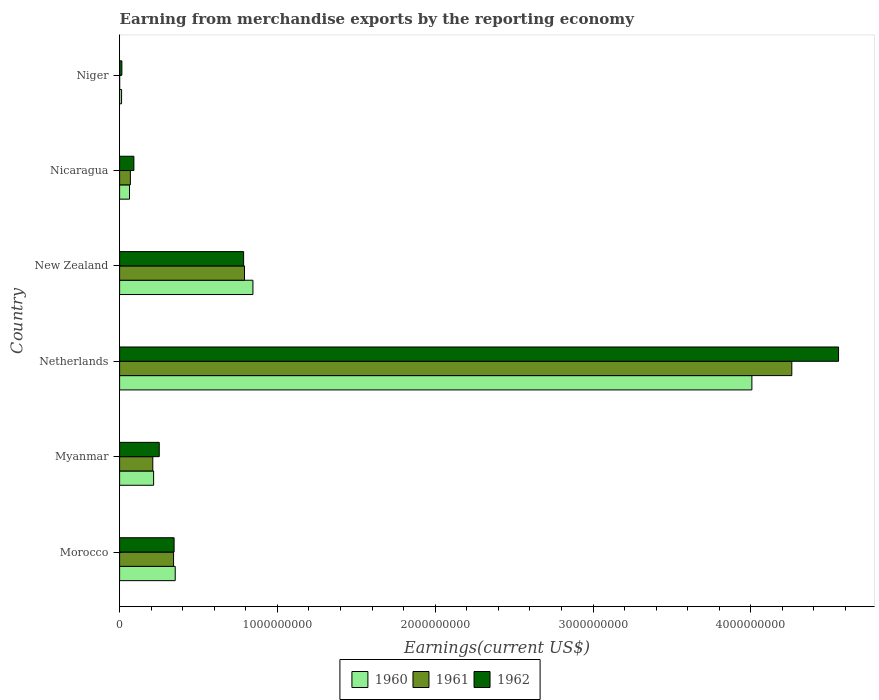How many different coloured bars are there?
Provide a succinct answer. 3. How many groups of bars are there?
Make the answer very short. 6. Are the number of bars per tick equal to the number of legend labels?
Keep it short and to the point. Yes. In how many cases, is the number of bars for a given country not equal to the number of legend labels?
Provide a succinct answer. 0. What is the amount earned from merchandise exports in 1962 in Myanmar?
Your response must be concise. 2.51e+08. Across all countries, what is the maximum amount earned from merchandise exports in 1960?
Offer a very short reply. 4.01e+09. Across all countries, what is the minimum amount earned from merchandise exports in 1960?
Provide a succinct answer. 1.25e+07. In which country was the amount earned from merchandise exports in 1962 maximum?
Offer a very short reply. Netherlands. In which country was the amount earned from merchandise exports in 1962 minimum?
Your answer should be very brief. Niger. What is the total amount earned from merchandise exports in 1960 in the graph?
Your answer should be compact. 5.49e+09. What is the difference between the amount earned from merchandise exports in 1961 in Nicaragua and that in Niger?
Offer a very short reply. 6.81e+07. What is the difference between the amount earned from merchandise exports in 1960 in Myanmar and the amount earned from merchandise exports in 1961 in Niger?
Keep it short and to the point. 2.15e+08. What is the average amount earned from merchandise exports in 1960 per country?
Your answer should be very brief. 9.16e+08. What is the difference between the amount earned from merchandise exports in 1962 and amount earned from merchandise exports in 1960 in Niger?
Your answer should be compact. 1.90e+06. In how many countries, is the amount earned from merchandise exports in 1960 greater than 800000000 US$?
Keep it short and to the point. 2. What is the ratio of the amount earned from merchandise exports in 1960 in New Zealand to that in Niger?
Keep it short and to the point. 67.59. Is the amount earned from merchandise exports in 1961 in New Zealand less than that in Nicaragua?
Offer a very short reply. No. What is the difference between the highest and the second highest amount earned from merchandise exports in 1960?
Keep it short and to the point. 3.16e+09. What is the difference between the highest and the lowest amount earned from merchandise exports in 1961?
Offer a very short reply. 4.26e+09. What does the 1st bar from the top in Netherlands represents?
Offer a very short reply. 1962. Is it the case that in every country, the sum of the amount earned from merchandise exports in 1962 and amount earned from merchandise exports in 1960 is greater than the amount earned from merchandise exports in 1961?
Keep it short and to the point. Yes. How many bars are there?
Provide a short and direct response. 18. How many countries are there in the graph?
Make the answer very short. 6. Are the values on the major ticks of X-axis written in scientific E-notation?
Give a very brief answer. No. Does the graph contain grids?
Your answer should be compact. No. Where does the legend appear in the graph?
Ensure brevity in your answer.  Bottom center. What is the title of the graph?
Your response must be concise. Earning from merchandise exports by the reporting economy. Does "2006" appear as one of the legend labels in the graph?
Offer a terse response. No. What is the label or title of the X-axis?
Your response must be concise. Earnings(current US$). What is the label or title of the Y-axis?
Make the answer very short. Country. What is the Earnings(current US$) in 1960 in Morocco?
Make the answer very short. 3.52e+08. What is the Earnings(current US$) of 1961 in Morocco?
Make the answer very short. 3.42e+08. What is the Earnings(current US$) in 1962 in Morocco?
Make the answer very short. 3.45e+08. What is the Earnings(current US$) in 1960 in Myanmar?
Offer a very short reply. 2.16e+08. What is the Earnings(current US$) of 1961 in Myanmar?
Provide a short and direct response. 2.10e+08. What is the Earnings(current US$) of 1962 in Myanmar?
Offer a terse response. 2.51e+08. What is the Earnings(current US$) of 1960 in Netherlands?
Your answer should be compact. 4.01e+09. What is the Earnings(current US$) in 1961 in Netherlands?
Your answer should be very brief. 4.26e+09. What is the Earnings(current US$) of 1962 in Netherlands?
Your response must be concise. 4.56e+09. What is the Earnings(current US$) in 1960 in New Zealand?
Offer a very short reply. 8.45e+08. What is the Earnings(current US$) in 1961 in New Zealand?
Your response must be concise. 7.92e+08. What is the Earnings(current US$) in 1962 in New Zealand?
Provide a short and direct response. 7.86e+08. What is the Earnings(current US$) in 1960 in Nicaragua?
Keep it short and to the point. 6.27e+07. What is the Earnings(current US$) in 1961 in Nicaragua?
Provide a short and direct response. 6.83e+07. What is the Earnings(current US$) in 1962 in Nicaragua?
Your answer should be very brief. 9.04e+07. What is the Earnings(current US$) of 1960 in Niger?
Ensure brevity in your answer.  1.25e+07. What is the Earnings(current US$) in 1962 in Niger?
Ensure brevity in your answer.  1.44e+07. Across all countries, what is the maximum Earnings(current US$) of 1960?
Provide a succinct answer. 4.01e+09. Across all countries, what is the maximum Earnings(current US$) in 1961?
Provide a short and direct response. 4.26e+09. Across all countries, what is the maximum Earnings(current US$) in 1962?
Give a very brief answer. 4.56e+09. Across all countries, what is the minimum Earnings(current US$) of 1960?
Provide a short and direct response. 1.25e+07. Across all countries, what is the minimum Earnings(current US$) of 1961?
Provide a short and direct response. 2.00e+05. Across all countries, what is the minimum Earnings(current US$) in 1962?
Keep it short and to the point. 1.44e+07. What is the total Earnings(current US$) of 1960 in the graph?
Provide a short and direct response. 5.49e+09. What is the total Earnings(current US$) of 1961 in the graph?
Provide a succinct answer. 5.67e+09. What is the total Earnings(current US$) in 1962 in the graph?
Keep it short and to the point. 6.04e+09. What is the difference between the Earnings(current US$) in 1960 in Morocco and that in Myanmar?
Provide a succinct answer. 1.37e+08. What is the difference between the Earnings(current US$) of 1961 in Morocco and that in Myanmar?
Your answer should be compact. 1.32e+08. What is the difference between the Earnings(current US$) in 1962 in Morocco and that in Myanmar?
Keep it short and to the point. 9.41e+07. What is the difference between the Earnings(current US$) in 1960 in Morocco and that in Netherlands?
Offer a very short reply. -3.65e+09. What is the difference between the Earnings(current US$) of 1961 in Morocco and that in Netherlands?
Keep it short and to the point. -3.92e+09. What is the difference between the Earnings(current US$) of 1962 in Morocco and that in Netherlands?
Your response must be concise. -4.21e+09. What is the difference between the Earnings(current US$) in 1960 in Morocco and that in New Zealand?
Provide a succinct answer. -4.92e+08. What is the difference between the Earnings(current US$) in 1961 in Morocco and that in New Zealand?
Offer a terse response. -4.50e+08. What is the difference between the Earnings(current US$) of 1962 in Morocco and that in New Zealand?
Your answer should be compact. -4.41e+08. What is the difference between the Earnings(current US$) in 1960 in Morocco and that in Nicaragua?
Make the answer very short. 2.90e+08. What is the difference between the Earnings(current US$) in 1961 in Morocco and that in Nicaragua?
Provide a short and direct response. 2.74e+08. What is the difference between the Earnings(current US$) in 1962 in Morocco and that in Nicaragua?
Your answer should be very brief. 2.55e+08. What is the difference between the Earnings(current US$) of 1960 in Morocco and that in Niger?
Give a very brief answer. 3.40e+08. What is the difference between the Earnings(current US$) of 1961 in Morocco and that in Niger?
Offer a terse response. 3.42e+08. What is the difference between the Earnings(current US$) of 1962 in Morocco and that in Niger?
Ensure brevity in your answer.  3.31e+08. What is the difference between the Earnings(current US$) in 1960 in Myanmar and that in Netherlands?
Keep it short and to the point. -3.79e+09. What is the difference between the Earnings(current US$) of 1961 in Myanmar and that in Netherlands?
Provide a succinct answer. -4.05e+09. What is the difference between the Earnings(current US$) of 1962 in Myanmar and that in Netherlands?
Provide a succinct answer. -4.30e+09. What is the difference between the Earnings(current US$) in 1960 in Myanmar and that in New Zealand?
Your response must be concise. -6.29e+08. What is the difference between the Earnings(current US$) of 1961 in Myanmar and that in New Zealand?
Your answer should be very brief. -5.81e+08. What is the difference between the Earnings(current US$) in 1962 in Myanmar and that in New Zealand?
Your answer should be compact. -5.35e+08. What is the difference between the Earnings(current US$) of 1960 in Myanmar and that in Nicaragua?
Provide a short and direct response. 1.53e+08. What is the difference between the Earnings(current US$) of 1961 in Myanmar and that in Nicaragua?
Keep it short and to the point. 1.42e+08. What is the difference between the Earnings(current US$) in 1962 in Myanmar and that in Nicaragua?
Ensure brevity in your answer.  1.61e+08. What is the difference between the Earnings(current US$) of 1960 in Myanmar and that in Niger?
Your response must be concise. 2.03e+08. What is the difference between the Earnings(current US$) in 1961 in Myanmar and that in Niger?
Offer a very short reply. 2.10e+08. What is the difference between the Earnings(current US$) in 1962 in Myanmar and that in Niger?
Offer a terse response. 2.37e+08. What is the difference between the Earnings(current US$) in 1960 in Netherlands and that in New Zealand?
Keep it short and to the point. 3.16e+09. What is the difference between the Earnings(current US$) in 1961 in Netherlands and that in New Zealand?
Offer a very short reply. 3.47e+09. What is the difference between the Earnings(current US$) in 1962 in Netherlands and that in New Zealand?
Provide a short and direct response. 3.77e+09. What is the difference between the Earnings(current US$) in 1960 in Netherlands and that in Nicaragua?
Your answer should be compact. 3.94e+09. What is the difference between the Earnings(current US$) in 1961 in Netherlands and that in Nicaragua?
Provide a succinct answer. 4.19e+09. What is the difference between the Earnings(current US$) in 1962 in Netherlands and that in Nicaragua?
Provide a short and direct response. 4.47e+09. What is the difference between the Earnings(current US$) in 1960 in Netherlands and that in Niger?
Provide a short and direct response. 3.99e+09. What is the difference between the Earnings(current US$) in 1961 in Netherlands and that in Niger?
Offer a very short reply. 4.26e+09. What is the difference between the Earnings(current US$) of 1962 in Netherlands and that in Niger?
Ensure brevity in your answer.  4.54e+09. What is the difference between the Earnings(current US$) in 1960 in New Zealand and that in Nicaragua?
Provide a short and direct response. 7.82e+08. What is the difference between the Earnings(current US$) in 1961 in New Zealand and that in Nicaragua?
Your answer should be very brief. 7.23e+08. What is the difference between the Earnings(current US$) in 1962 in New Zealand and that in Nicaragua?
Your answer should be very brief. 6.96e+08. What is the difference between the Earnings(current US$) in 1960 in New Zealand and that in Niger?
Give a very brief answer. 8.32e+08. What is the difference between the Earnings(current US$) of 1961 in New Zealand and that in Niger?
Give a very brief answer. 7.91e+08. What is the difference between the Earnings(current US$) in 1962 in New Zealand and that in Niger?
Make the answer very short. 7.72e+08. What is the difference between the Earnings(current US$) of 1960 in Nicaragua and that in Niger?
Your answer should be very brief. 5.02e+07. What is the difference between the Earnings(current US$) of 1961 in Nicaragua and that in Niger?
Offer a terse response. 6.81e+07. What is the difference between the Earnings(current US$) in 1962 in Nicaragua and that in Niger?
Ensure brevity in your answer.  7.60e+07. What is the difference between the Earnings(current US$) in 1960 in Morocco and the Earnings(current US$) in 1961 in Myanmar?
Your answer should be compact. 1.42e+08. What is the difference between the Earnings(current US$) of 1960 in Morocco and the Earnings(current US$) of 1962 in Myanmar?
Offer a very short reply. 1.01e+08. What is the difference between the Earnings(current US$) of 1961 in Morocco and the Earnings(current US$) of 1962 in Myanmar?
Keep it short and to the point. 9.07e+07. What is the difference between the Earnings(current US$) of 1960 in Morocco and the Earnings(current US$) of 1961 in Netherlands?
Your answer should be very brief. -3.91e+09. What is the difference between the Earnings(current US$) in 1960 in Morocco and the Earnings(current US$) in 1962 in Netherlands?
Offer a terse response. -4.20e+09. What is the difference between the Earnings(current US$) in 1961 in Morocco and the Earnings(current US$) in 1962 in Netherlands?
Give a very brief answer. -4.21e+09. What is the difference between the Earnings(current US$) in 1960 in Morocco and the Earnings(current US$) in 1961 in New Zealand?
Offer a terse response. -4.39e+08. What is the difference between the Earnings(current US$) in 1960 in Morocco and the Earnings(current US$) in 1962 in New Zealand?
Ensure brevity in your answer.  -4.34e+08. What is the difference between the Earnings(current US$) in 1961 in Morocco and the Earnings(current US$) in 1962 in New Zealand?
Ensure brevity in your answer.  -4.44e+08. What is the difference between the Earnings(current US$) of 1960 in Morocco and the Earnings(current US$) of 1961 in Nicaragua?
Provide a succinct answer. 2.84e+08. What is the difference between the Earnings(current US$) in 1960 in Morocco and the Earnings(current US$) in 1962 in Nicaragua?
Make the answer very short. 2.62e+08. What is the difference between the Earnings(current US$) of 1961 in Morocco and the Earnings(current US$) of 1962 in Nicaragua?
Your answer should be very brief. 2.52e+08. What is the difference between the Earnings(current US$) of 1960 in Morocco and the Earnings(current US$) of 1961 in Niger?
Provide a short and direct response. 3.52e+08. What is the difference between the Earnings(current US$) in 1960 in Morocco and the Earnings(current US$) in 1962 in Niger?
Offer a very short reply. 3.38e+08. What is the difference between the Earnings(current US$) in 1961 in Morocco and the Earnings(current US$) in 1962 in Niger?
Provide a short and direct response. 3.28e+08. What is the difference between the Earnings(current US$) in 1960 in Myanmar and the Earnings(current US$) in 1961 in Netherlands?
Ensure brevity in your answer.  -4.04e+09. What is the difference between the Earnings(current US$) of 1960 in Myanmar and the Earnings(current US$) of 1962 in Netherlands?
Your response must be concise. -4.34e+09. What is the difference between the Earnings(current US$) of 1961 in Myanmar and the Earnings(current US$) of 1962 in Netherlands?
Your answer should be very brief. -4.35e+09. What is the difference between the Earnings(current US$) in 1960 in Myanmar and the Earnings(current US$) in 1961 in New Zealand?
Your answer should be compact. -5.76e+08. What is the difference between the Earnings(current US$) in 1960 in Myanmar and the Earnings(current US$) in 1962 in New Zealand?
Provide a short and direct response. -5.70e+08. What is the difference between the Earnings(current US$) in 1961 in Myanmar and the Earnings(current US$) in 1962 in New Zealand?
Provide a succinct answer. -5.76e+08. What is the difference between the Earnings(current US$) of 1960 in Myanmar and the Earnings(current US$) of 1961 in Nicaragua?
Your answer should be compact. 1.47e+08. What is the difference between the Earnings(current US$) in 1960 in Myanmar and the Earnings(current US$) in 1962 in Nicaragua?
Your response must be concise. 1.25e+08. What is the difference between the Earnings(current US$) in 1961 in Myanmar and the Earnings(current US$) in 1962 in Nicaragua?
Provide a succinct answer. 1.20e+08. What is the difference between the Earnings(current US$) in 1960 in Myanmar and the Earnings(current US$) in 1961 in Niger?
Provide a short and direct response. 2.15e+08. What is the difference between the Earnings(current US$) of 1960 in Myanmar and the Earnings(current US$) of 1962 in Niger?
Make the answer very short. 2.01e+08. What is the difference between the Earnings(current US$) of 1961 in Myanmar and the Earnings(current US$) of 1962 in Niger?
Your answer should be very brief. 1.96e+08. What is the difference between the Earnings(current US$) in 1960 in Netherlands and the Earnings(current US$) in 1961 in New Zealand?
Ensure brevity in your answer.  3.22e+09. What is the difference between the Earnings(current US$) of 1960 in Netherlands and the Earnings(current US$) of 1962 in New Zealand?
Ensure brevity in your answer.  3.22e+09. What is the difference between the Earnings(current US$) in 1961 in Netherlands and the Earnings(current US$) in 1962 in New Zealand?
Keep it short and to the point. 3.47e+09. What is the difference between the Earnings(current US$) in 1960 in Netherlands and the Earnings(current US$) in 1961 in Nicaragua?
Give a very brief answer. 3.94e+09. What is the difference between the Earnings(current US$) of 1960 in Netherlands and the Earnings(current US$) of 1962 in Nicaragua?
Your response must be concise. 3.92e+09. What is the difference between the Earnings(current US$) in 1961 in Netherlands and the Earnings(current US$) in 1962 in Nicaragua?
Your response must be concise. 4.17e+09. What is the difference between the Earnings(current US$) of 1960 in Netherlands and the Earnings(current US$) of 1961 in Niger?
Your answer should be compact. 4.01e+09. What is the difference between the Earnings(current US$) in 1960 in Netherlands and the Earnings(current US$) in 1962 in Niger?
Provide a succinct answer. 3.99e+09. What is the difference between the Earnings(current US$) of 1961 in Netherlands and the Earnings(current US$) of 1962 in Niger?
Ensure brevity in your answer.  4.25e+09. What is the difference between the Earnings(current US$) in 1960 in New Zealand and the Earnings(current US$) in 1961 in Nicaragua?
Your response must be concise. 7.77e+08. What is the difference between the Earnings(current US$) of 1960 in New Zealand and the Earnings(current US$) of 1962 in Nicaragua?
Give a very brief answer. 7.54e+08. What is the difference between the Earnings(current US$) in 1961 in New Zealand and the Earnings(current US$) in 1962 in Nicaragua?
Provide a short and direct response. 7.01e+08. What is the difference between the Earnings(current US$) of 1960 in New Zealand and the Earnings(current US$) of 1961 in Niger?
Your answer should be very brief. 8.45e+08. What is the difference between the Earnings(current US$) in 1960 in New Zealand and the Earnings(current US$) in 1962 in Niger?
Offer a very short reply. 8.30e+08. What is the difference between the Earnings(current US$) of 1961 in New Zealand and the Earnings(current US$) of 1962 in Niger?
Your answer should be very brief. 7.77e+08. What is the difference between the Earnings(current US$) in 1960 in Nicaragua and the Earnings(current US$) in 1961 in Niger?
Offer a very short reply. 6.25e+07. What is the difference between the Earnings(current US$) of 1960 in Nicaragua and the Earnings(current US$) of 1962 in Niger?
Your answer should be very brief. 4.83e+07. What is the difference between the Earnings(current US$) of 1961 in Nicaragua and the Earnings(current US$) of 1962 in Niger?
Make the answer very short. 5.39e+07. What is the average Earnings(current US$) of 1960 per country?
Make the answer very short. 9.16e+08. What is the average Earnings(current US$) in 1961 per country?
Your response must be concise. 9.45e+08. What is the average Earnings(current US$) of 1962 per country?
Your answer should be very brief. 1.01e+09. What is the difference between the Earnings(current US$) in 1960 and Earnings(current US$) in 1961 in Morocco?
Provide a succinct answer. 1.05e+07. What is the difference between the Earnings(current US$) of 1960 and Earnings(current US$) of 1962 in Morocco?
Keep it short and to the point. 7.10e+06. What is the difference between the Earnings(current US$) of 1961 and Earnings(current US$) of 1962 in Morocco?
Make the answer very short. -3.40e+06. What is the difference between the Earnings(current US$) of 1960 and Earnings(current US$) of 1961 in Myanmar?
Provide a succinct answer. 5.20e+06. What is the difference between the Earnings(current US$) of 1960 and Earnings(current US$) of 1962 in Myanmar?
Offer a terse response. -3.57e+07. What is the difference between the Earnings(current US$) in 1961 and Earnings(current US$) in 1962 in Myanmar?
Offer a terse response. -4.09e+07. What is the difference between the Earnings(current US$) in 1960 and Earnings(current US$) in 1961 in Netherlands?
Offer a terse response. -2.53e+08. What is the difference between the Earnings(current US$) in 1960 and Earnings(current US$) in 1962 in Netherlands?
Provide a short and direct response. -5.49e+08. What is the difference between the Earnings(current US$) of 1961 and Earnings(current US$) of 1962 in Netherlands?
Give a very brief answer. -2.96e+08. What is the difference between the Earnings(current US$) of 1960 and Earnings(current US$) of 1961 in New Zealand?
Your answer should be very brief. 5.34e+07. What is the difference between the Earnings(current US$) of 1960 and Earnings(current US$) of 1962 in New Zealand?
Ensure brevity in your answer.  5.90e+07. What is the difference between the Earnings(current US$) in 1961 and Earnings(current US$) in 1962 in New Zealand?
Keep it short and to the point. 5.60e+06. What is the difference between the Earnings(current US$) in 1960 and Earnings(current US$) in 1961 in Nicaragua?
Your answer should be compact. -5.60e+06. What is the difference between the Earnings(current US$) of 1960 and Earnings(current US$) of 1962 in Nicaragua?
Provide a short and direct response. -2.77e+07. What is the difference between the Earnings(current US$) in 1961 and Earnings(current US$) in 1962 in Nicaragua?
Keep it short and to the point. -2.21e+07. What is the difference between the Earnings(current US$) in 1960 and Earnings(current US$) in 1961 in Niger?
Keep it short and to the point. 1.23e+07. What is the difference between the Earnings(current US$) in 1960 and Earnings(current US$) in 1962 in Niger?
Your answer should be very brief. -1.90e+06. What is the difference between the Earnings(current US$) in 1961 and Earnings(current US$) in 1962 in Niger?
Your answer should be compact. -1.42e+07. What is the ratio of the Earnings(current US$) in 1960 in Morocco to that in Myanmar?
Provide a succinct answer. 1.64. What is the ratio of the Earnings(current US$) in 1961 in Morocco to that in Myanmar?
Your answer should be very brief. 1.63. What is the ratio of the Earnings(current US$) of 1962 in Morocco to that in Myanmar?
Offer a very short reply. 1.37. What is the ratio of the Earnings(current US$) in 1960 in Morocco to that in Netherlands?
Provide a short and direct response. 0.09. What is the ratio of the Earnings(current US$) in 1961 in Morocco to that in Netherlands?
Your response must be concise. 0.08. What is the ratio of the Earnings(current US$) of 1962 in Morocco to that in Netherlands?
Offer a very short reply. 0.08. What is the ratio of the Earnings(current US$) of 1960 in Morocco to that in New Zealand?
Your answer should be very brief. 0.42. What is the ratio of the Earnings(current US$) in 1961 in Morocco to that in New Zealand?
Keep it short and to the point. 0.43. What is the ratio of the Earnings(current US$) of 1962 in Morocco to that in New Zealand?
Make the answer very short. 0.44. What is the ratio of the Earnings(current US$) in 1960 in Morocco to that in Nicaragua?
Make the answer very short. 5.62. What is the ratio of the Earnings(current US$) of 1961 in Morocco to that in Nicaragua?
Provide a short and direct response. 5.01. What is the ratio of the Earnings(current US$) in 1962 in Morocco to that in Nicaragua?
Your answer should be compact. 3.82. What is the ratio of the Earnings(current US$) of 1960 in Morocco to that in Niger?
Ensure brevity in your answer.  28.19. What is the ratio of the Earnings(current US$) of 1961 in Morocco to that in Niger?
Provide a short and direct response. 1709.5. What is the ratio of the Earnings(current US$) in 1962 in Morocco to that in Niger?
Give a very brief answer. 23.98. What is the ratio of the Earnings(current US$) in 1960 in Myanmar to that in Netherlands?
Offer a very short reply. 0.05. What is the ratio of the Earnings(current US$) in 1961 in Myanmar to that in Netherlands?
Provide a short and direct response. 0.05. What is the ratio of the Earnings(current US$) of 1962 in Myanmar to that in Netherlands?
Offer a very short reply. 0.06. What is the ratio of the Earnings(current US$) in 1960 in Myanmar to that in New Zealand?
Your answer should be very brief. 0.26. What is the ratio of the Earnings(current US$) of 1961 in Myanmar to that in New Zealand?
Your answer should be very brief. 0.27. What is the ratio of the Earnings(current US$) in 1962 in Myanmar to that in New Zealand?
Provide a short and direct response. 0.32. What is the ratio of the Earnings(current US$) of 1960 in Myanmar to that in Nicaragua?
Provide a short and direct response. 3.44. What is the ratio of the Earnings(current US$) of 1961 in Myanmar to that in Nicaragua?
Offer a very short reply. 3.08. What is the ratio of the Earnings(current US$) in 1962 in Myanmar to that in Nicaragua?
Your answer should be compact. 2.78. What is the ratio of the Earnings(current US$) of 1960 in Myanmar to that in Niger?
Provide a succinct answer. 17.24. What is the ratio of the Earnings(current US$) of 1961 in Myanmar to that in Niger?
Provide a short and direct response. 1051.5. What is the ratio of the Earnings(current US$) in 1962 in Myanmar to that in Niger?
Provide a short and direct response. 17.44. What is the ratio of the Earnings(current US$) of 1960 in Netherlands to that in New Zealand?
Your response must be concise. 4.74. What is the ratio of the Earnings(current US$) in 1961 in Netherlands to that in New Zealand?
Provide a succinct answer. 5.38. What is the ratio of the Earnings(current US$) of 1962 in Netherlands to that in New Zealand?
Keep it short and to the point. 5.8. What is the ratio of the Earnings(current US$) of 1960 in Netherlands to that in Nicaragua?
Ensure brevity in your answer.  63.9. What is the ratio of the Earnings(current US$) in 1961 in Netherlands to that in Nicaragua?
Your response must be concise. 62.37. What is the ratio of the Earnings(current US$) of 1962 in Netherlands to that in Nicaragua?
Your response must be concise. 50.4. What is the ratio of the Earnings(current US$) of 1960 in Netherlands to that in Niger?
Keep it short and to the point. 320.54. What is the ratio of the Earnings(current US$) in 1961 in Netherlands to that in Niger?
Provide a short and direct response. 2.13e+04. What is the ratio of the Earnings(current US$) in 1962 in Netherlands to that in Niger?
Give a very brief answer. 316.38. What is the ratio of the Earnings(current US$) of 1960 in New Zealand to that in Nicaragua?
Make the answer very short. 13.48. What is the ratio of the Earnings(current US$) in 1961 in New Zealand to that in Nicaragua?
Your response must be concise. 11.59. What is the ratio of the Earnings(current US$) of 1962 in New Zealand to that in Nicaragua?
Provide a short and direct response. 8.69. What is the ratio of the Earnings(current US$) in 1960 in New Zealand to that in Niger?
Make the answer very short. 67.59. What is the ratio of the Earnings(current US$) of 1961 in New Zealand to that in Niger?
Offer a terse response. 3957.5. What is the ratio of the Earnings(current US$) of 1962 in New Zealand to that in Niger?
Your response must be concise. 54.58. What is the ratio of the Earnings(current US$) of 1960 in Nicaragua to that in Niger?
Keep it short and to the point. 5.02. What is the ratio of the Earnings(current US$) of 1961 in Nicaragua to that in Niger?
Offer a terse response. 341.5. What is the ratio of the Earnings(current US$) of 1962 in Nicaragua to that in Niger?
Provide a short and direct response. 6.28. What is the difference between the highest and the second highest Earnings(current US$) of 1960?
Provide a succinct answer. 3.16e+09. What is the difference between the highest and the second highest Earnings(current US$) of 1961?
Your answer should be compact. 3.47e+09. What is the difference between the highest and the second highest Earnings(current US$) in 1962?
Provide a short and direct response. 3.77e+09. What is the difference between the highest and the lowest Earnings(current US$) of 1960?
Offer a terse response. 3.99e+09. What is the difference between the highest and the lowest Earnings(current US$) in 1961?
Provide a short and direct response. 4.26e+09. What is the difference between the highest and the lowest Earnings(current US$) of 1962?
Offer a terse response. 4.54e+09. 